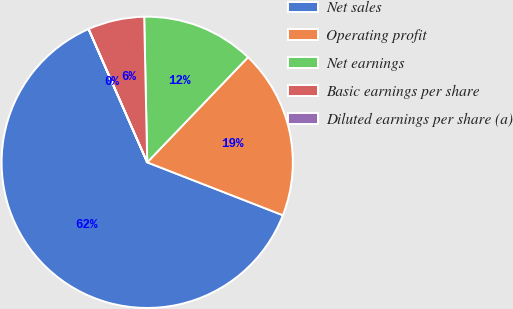<chart> <loc_0><loc_0><loc_500><loc_500><pie_chart><fcel>Net sales<fcel>Operating profit<fcel>Net earnings<fcel>Basic earnings per share<fcel>Diluted earnings per share (a)<nl><fcel>62.48%<fcel>18.75%<fcel>12.5%<fcel>6.26%<fcel>0.01%<nl></chart> 